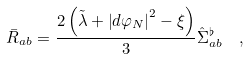Convert formula to latex. <formula><loc_0><loc_0><loc_500><loc_500>\bar { R } _ { a b } & = \frac { 2 \left ( \tilde { \lambda } + \left | d \varphi _ { N } \right | ^ { 2 } - \xi \right ) } { 3 } \hat { \Sigma } ^ { \flat } _ { a b } \quad ,</formula> 